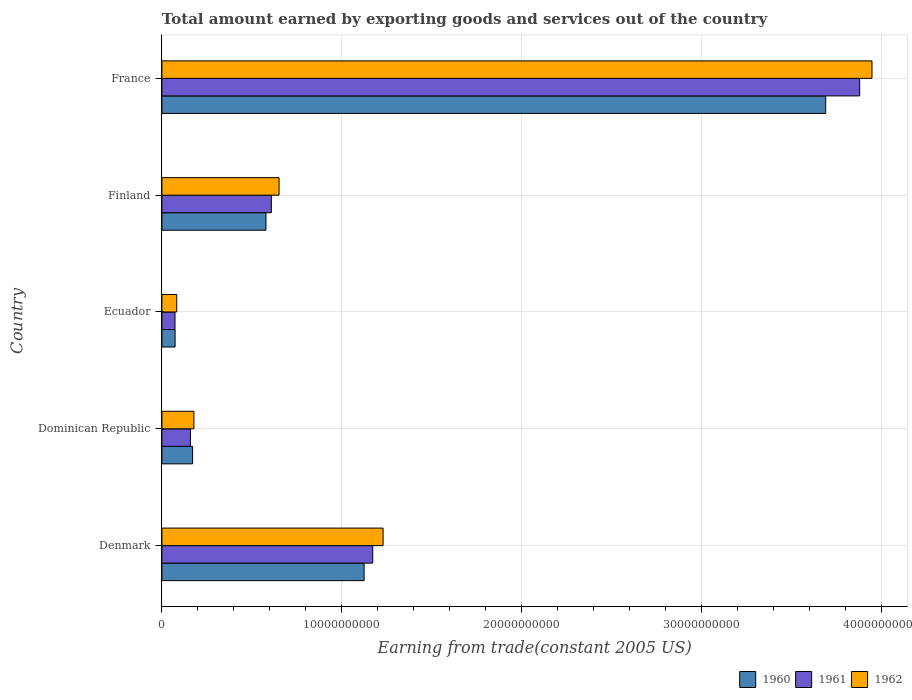How many different coloured bars are there?
Offer a terse response. 3. How many groups of bars are there?
Provide a succinct answer. 5. Are the number of bars per tick equal to the number of legend labels?
Your answer should be compact. Yes. How many bars are there on the 2nd tick from the top?
Your answer should be very brief. 3. How many bars are there on the 5th tick from the bottom?
Provide a short and direct response. 3. In how many cases, is the number of bars for a given country not equal to the number of legend labels?
Provide a short and direct response. 0. What is the total amount earned by exporting goods and services in 1961 in Ecuador?
Make the answer very short. 7.28e+08. Across all countries, what is the maximum total amount earned by exporting goods and services in 1961?
Make the answer very short. 3.88e+1. Across all countries, what is the minimum total amount earned by exporting goods and services in 1962?
Make the answer very short. 8.25e+08. In which country was the total amount earned by exporting goods and services in 1962 maximum?
Offer a very short reply. France. In which country was the total amount earned by exporting goods and services in 1962 minimum?
Ensure brevity in your answer.  Ecuador. What is the total total amount earned by exporting goods and services in 1960 in the graph?
Your answer should be very brief. 5.64e+1. What is the difference between the total amount earned by exporting goods and services in 1962 in Denmark and that in Dominican Republic?
Give a very brief answer. 1.05e+1. What is the difference between the total amount earned by exporting goods and services in 1961 in France and the total amount earned by exporting goods and services in 1962 in Dominican Republic?
Offer a very short reply. 3.70e+1. What is the average total amount earned by exporting goods and services in 1960 per country?
Provide a short and direct response. 1.13e+1. What is the difference between the total amount earned by exporting goods and services in 1961 and total amount earned by exporting goods and services in 1960 in Dominican Republic?
Give a very brief answer. -1.20e+08. What is the ratio of the total amount earned by exporting goods and services in 1962 in Ecuador to that in France?
Your answer should be very brief. 0.02. Is the difference between the total amount earned by exporting goods and services in 1961 in Dominican Republic and France greater than the difference between the total amount earned by exporting goods and services in 1960 in Dominican Republic and France?
Provide a succinct answer. No. What is the difference between the highest and the second highest total amount earned by exporting goods and services in 1961?
Offer a terse response. 2.71e+1. What is the difference between the highest and the lowest total amount earned by exporting goods and services in 1962?
Your response must be concise. 3.86e+1. What does the 2nd bar from the top in Dominican Republic represents?
Make the answer very short. 1961. Is it the case that in every country, the sum of the total amount earned by exporting goods and services in 1961 and total amount earned by exporting goods and services in 1962 is greater than the total amount earned by exporting goods and services in 1960?
Provide a short and direct response. Yes. How many bars are there?
Provide a short and direct response. 15. Are the values on the major ticks of X-axis written in scientific E-notation?
Provide a short and direct response. No. Does the graph contain any zero values?
Keep it short and to the point. No. What is the title of the graph?
Give a very brief answer. Total amount earned by exporting goods and services out of the country. Does "2011" appear as one of the legend labels in the graph?
Your answer should be very brief. No. What is the label or title of the X-axis?
Give a very brief answer. Earning from trade(constant 2005 US). What is the label or title of the Y-axis?
Your answer should be compact. Country. What is the Earning from trade(constant 2005 US) of 1960 in Denmark?
Offer a terse response. 1.12e+1. What is the Earning from trade(constant 2005 US) of 1961 in Denmark?
Offer a very short reply. 1.17e+1. What is the Earning from trade(constant 2005 US) of 1962 in Denmark?
Your response must be concise. 1.23e+1. What is the Earning from trade(constant 2005 US) in 1960 in Dominican Republic?
Provide a succinct answer. 1.71e+09. What is the Earning from trade(constant 2005 US) of 1961 in Dominican Republic?
Ensure brevity in your answer.  1.59e+09. What is the Earning from trade(constant 2005 US) in 1962 in Dominican Republic?
Keep it short and to the point. 1.78e+09. What is the Earning from trade(constant 2005 US) of 1960 in Ecuador?
Provide a succinct answer. 7.33e+08. What is the Earning from trade(constant 2005 US) in 1961 in Ecuador?
Provide a short and direct response. 7.28e+08. What is the Earning from trade(constant 2005 US) of 1962 in Ecuador?
Provide a short and direct response. 8.25e+08. What is the Earning from trade(constant 2005 US) of 1960 in Finland?
Ensure brevity in your answer.  5.78e+09. What is the Earning from trade(constant 2005 US) of 1961 in Finland?
Your answer should be compact. 6.08e+09. What is the Earning from trade(constant 2005 US) of 1962 in Finland?
Your answer should be very brief. 6.51e+09. What is the Earning from trade(constant 2005 US) in 1960 in France?
Give a very brief answer. 3.69e+1. What is the Earning from trade(constant 2005 US) of 1961 in France?
Offer a very short reply. 3.88e+1. What is the Earning from trade(constant 2005 US) in 1962 in France?
Provide a short and direct response. 3.95e+1. Across all countries, what is the maximum Earning from trade(constant 2005 US) in 1960?
Provide a succinct answer. 3.69e+1. Across all countries, what is the maximum Earning from trade(constant 2005 US) in 1961?
Keep it short and to the point. 3.88e+1. Across all countries, what is the maximum Earning from trade(constant 2005 US) in 1962?
Your answer should be very brief. 3.95e+1. Across all countries, what is the minimum Earning from trade(constant 2005 US) in 1960?
Offer a terse response. 7.33e+08. Across all countries, what is the minimum Earning from trade(constant 2005 US) in 1961?
Offer a very short reply. 7.28e+08. Across all countries, what is the minimum Earning from trade(constant 2005 US) of 1962?
Your answer should be compact. 8.25e+08. What is the total Earning from trade(constant 2005 US) in 1960 in the graph?
Ensure brevity in your answer.  5.64e+1. What is the total Earning from trade(constant 2005 US) in 1961 in the graph?
Offer a very short reply. 5.89e+1. What is the total Earning from trade(constant 2005 US) of 1962 in the graph?
Your answer should be very brief. 6.09e+1. What is the difference between the Earning from trade(constant 2005 US) in 1960 in Denmark and that in Dominican Republic?
Your answer should be compact. 9.53e+09. What is the difference between the Earning from trade(constant 2005 US) of 1961 in Denmark and that in Dominican Republic?
Keep it short and to the point. 1.01e+1. What is the difference between the Earning from trade(constant 2005 US) in 1962 in Denmark and that in Dominican Republic?
Ensure brevity in your answer.  1.05e+1. What is the difference between the Earning from trade(constant 2005 US) of 1960 in Denmark and that in Ecuador?
Your answer should be very brief. 1.05e+1. What is the difference between the Earning from trade(constant 2005 US) in 1961 in Denmark and that in Ecuador?
Your response must be concise. 1.10e+1. What is the difference between the Earning from trade(constant 2005 US) in 1962 in Denmark and that in Ecuador?
Provide a short and direct response. 1.15e+1. What is the difference between the Earning from trade(constant 2005 US) of 1960 in Denmark and that in Finland?
Make the answer very short. 5.45e+09. What is the difference between the Earning from trade(constant 2005 US) in 1961 in Denmark and that in Finland?
Keep it short and to the point. 5.64e+09. What is the difference between the Earning from trade(constant 2005 US) of 1962 in Denmark and that in Finland?
Your response must be concise. 5.78e+09. What is the difference between the Earning from trade(constant 2005 US) of 1960 in Denmark and that in France?
Offer a very short reply. -2.57e+1. What is the difference between the Earning from trade(constant 2005 US) in 1961 in Denmark and that in France?
Ensure brevity in your answer.  -2.71e+1. What is the difference between the Earning from trade(constant 2005 US) in 1962 in Denmark and that in France?
Make the answer very short. -2.72e+1. What is the difference between the Earning from trade(constant 2005 US) of 1960 in Dominican Republic and that in Ecuador?
Offer a terse response. 9.74e+08. What is the difference between the Earning from trade(constant 2005 US) in 1961 in Dominican Republic and that in Ecuador?
Make the answer very short. 8.59e+08. What is the difference between the Earning from trade(constant 2005 US) in 1962 in Dominican Republic and that in Ecuador?
Ensure brevity in your answer.  9.54e+08. What is the difference between the Earning from trade(constant 2005 US) in 1960 in Dominican Republic and that in Finland?
Offer a very short reply. -4.08e+09. What is the difference between the Earning from trade(constant 2005 US) in 1961 in Dominican Republic and that in Finland?
Your answer should be compact. -4.50e+09. What is the difference between the Earning from trade(constant 2005 US) of 1962 in Dominican Republic and that in Finland?
Give a very brief answer. -4.73e+09. What is the difference between the Earning from trade(constant 2005 US) in 1960 in Dominican Republic and that in France?
Ensure brevity in your answer.  -3.52e+1. What is the difference between the Earning from trade(constant 2005 US) of 1961 in Dominican Republic and that in France?
Offer a very short reply. -3.72e+1. What is the difference between the Earning from trade(constant 2005 US) in 1962 in Dominican Republic and that in France?
Offer a very short reply. -3.77e+1. What is the difference between the Earning from trade(constant 2005 US) in 1960 in Ecuador and that in Finland?
Offer a terse response. -5.05e+09. What is the difference between the Earning from trade(constant 2005 US) in 1961 in Ecuador and that in Finland?
Provide a succinct answer. -5.35e+09. What is the difference between the Earning from trade(constant 2005 US) in 1962 in Ecuador and that in Finland?
Ensure brevity in your answer.  -5.69e+09. What is the difference between the Earning from trade(constant 2005 US) in 1960 in Ecuador and that in France?
Give a very brief answer. -3.62e+1. What is the difference between the Earning from trade(constant 2005 US) in 1961 in Ecuador and that in France?
Ensure brevity in your answer.  -3.81e+1. What is the difference between the Earning from trade(constant 2005 US) of 1962 in Ecuador and that in France?
Your answer should be very brief. -3.86e+1. What is the difference between the Earning from trade(constant 2005 US) of 1960 in Finland and that in France?
Your answer should be compact. -3.11e+1. What is the difference between the Earning from trade(constant 2005 US) in 1961 in Finland and that in France?
Your answer should be very brief. -3.27e+1. What is the difference between the Earning from trade(constant 2005 US) of 1962 in Finland and that in France?
Provide a short and direct response. -3.30e+1. What is the difference between the Earning from trade(constant 2005 US) in 1960 in Denmark and the Earning from trade(constant 2005 US) in 1961 in Dominican Republic?
Provide a succinct answer. 9.65e+09. What is the difference between the Earning from trade(constant 2005 US) in 1960 in Denmark and the Earning from trade(constant 2005 US) in 1962 in Dominican Republic?
Make the answer very short. 9.46e+09. What is the difference between the Earning from trade(constant 2005 US) of 1961 in Denmark and the Earning from trade(constant 2005 US) of 1962 in Dominican Republic?
Your answer should be very brief. 9.94e+09. What is the difference between the Earning from trade(constant 2005 US) of 1960 in Denmark and the Earning from trade(constant 2005 US) of 1961 in Ecuador?
Ensure brevity in your answer.  1.05e+1. What is the difference between the Earning from trade(constant 2005 US) of 1960 in Denmark and the Earning from trade(constant 2005 US) of 1962 in Ecuador?
Offer a very short reply. 1.04e+1. What is the difference between the Earning from trade(constant 2005 US) of 1961 in Denmark and the Earning from trade(constant 2005 US) of 1962 in Ecuador?
Give a very brief answer. 1.09e+1. What is the difference between the Earning from trade(constant 2005 US) of 1960 in Denmark and the Earning from trade(constant 2005 US) of 1961 in Finland?
Make the answer very short. 5.16e+09. What is the difference between the Earning from trade(constant 2005 US) in 1960 in Denmark and the Earning from trade(constant 2005 US) in 1962 in Finland?
Your response must be concise. 4.73e+09. What is the difference between the Earning from trade(constant 2005 US) in 1961 in Denmark and the Earning from trade(constant 2005 US) in 1962 in Finland?
Your answer should be compact. 5.21e+09. What is the difference between the Earning from trade(constant 2005 US) in 1960 in Denmark and the Earning from trade(constant 2005 US) in 1961 in France?
Ensure brevity in your answer.  -2.75e+1. What is the difference between the Earning from trade(constant 2005 US) in 1960 in Denmark and the Earning from trade(constant 2005 US) in 1962 in France?
Your answer should be compact. -2.82e+1. What is the difference between the Earning from trade(constant 2005 US) in 1961 in Denmark and the Earning from trade(constant 2005 US) in 1962 in France?
Make the answer very short. -2.77e+1. What is the difference between the Earning from trade(constant 2005 US) in 1960 in Dominican Republic and the Earning from trade(constant 2005 US) in 1961 in Ecuador?
Give a very brief answer. 9.79e+08. What is the difference between the Earning from trade(constant 2005 US) in 1960 in Dominican Republic and the Earning from trade(constant 2005 US) in 1962 in Ecuador?
Provide a succinct answer. 8.81e+08. What is the difference between the Earning from trade(constant 2005 US) of 1961 in Dominican Republic and the Earning from trade(constant 2005 US) of 1962 in Ecuador?
Ensure brevity in your answer.  7.61e+08. What is the difference between the Earning from trade(constant 2005 US) of 1960 in Dominican Republic and the Earning from trade(constant 2005 US) of 1961 in Finland?
Keep it short and to the point. -4.38e+09. What is the difference between the Earning from trade(constant 2005 US) in 1960 in Dominican Republic and the Earning from trade(constant 2005 US) in 1962 in Finland?
Ensure brevity in your answer.  -4.81e+09. What is the difference between the Earning from trade(constant 2005 US) in 1961 in Dominican Republic and the Earning from trade(constant 2005 US) in 1962 in Finland?
Give a very brief answer. -4.93e+09. What is the difference between the Earning from trade(constant 2005 US) in 1960 in Dominican Republic and the Earning from trade(constant 2005 US) in 1961 in France?
Keep it short and to the point. -3.71e+1. What is the difference between the Earning from trade(constant 2005 US) in 1960 in Dominican Republic and the Earning from trade(constant 2005 US) in 1962 in France?
Ensure brevity in your answer.  -3.78e+1. What is the difference between the Earning from trade(constant 2005 US) of 1961 in Dominican Republic and the Earning from trade(constant 2005 US) of 1962 in France?
Your response must be concise. -3.79e+1. What is the difference between the Earning from trade(constant 2005 US) in 1960 in Ecuador and the Earning from trade(constant 2005 US) in 1961 in Finland?
Keep it short and to the point. -5.35e+09. What is the difference between the Earning from trade(constant 2005 US) in 1960 in Ecuador and the Earning from trade(constant 2005 US) in 1962 in Finland?
Provide a succinct answer. -5.78e+09. What is the difference between the Earning from trade(constant 2005 US) in 1961 in Ecuador and the Earning from trade(constant 2005 US) in 1962 in Finland?
Offer a very short reply. -5.78e+09. What is the difference between the Earning from trade(constant 2005 US) in 1960 in Ecuador and the Earning from trade(constant 2005 US) in 1961 in France?
Offer a terse response. -3.81e+1. What is the difference between the Earning from trade(constant 2005 US) in 1960 in Ecuador and the Earning from trade(constant 2005 US) in 1962 in France?
Offer a very short reply. -3.87e+1. What is the difference between the Earning from trade(constant 2005 US) of 1961 in Ecuador and the Earning from trade(constant 2005 US) of 1962 in France?
Offer a terse response. -3.87e+1. What is the difference between the Earning from trade(constant 2005 US) of 1960 in Finland and the Earning from trade(constant 2005 US) of 1961 in France?
Give a very brief answer. -3.30e+1. What is the difference between the Earning from trade(constant 2005 US) in 1960 in Finland and the Earning from trade(constant 2005 US) in 1962 in France?
Provide a short and direct response. -3.37e+1. What is the difference between the Earning from trade(constant 2005 US) of 1961 in Finland and the Earning from trade(constant 2005 US) of 1962 in France?
Your answer should be very brief. -3.34e+1. What is the average Earning from trade(constant 2005 US) of 1960 per country?
Offer a terse response. 1.13e+1. What is the average Earning from trade(constant 2005 US) of 1961 per country?
Provide a short and direct response. 1.18e+1. What is the average Earning from trade(constant 2005 US) of 1962 per country?
Ensure brevity in your answer.  1.22e+1. What is the difference between the Earning from trade(constant 2005 US) in 1960 and Earning from trade(constant 2005 US) in 1961 in Denmark?
Offer a terse response. -4.81e+08. What is the difference between the Earning from trade(constant 2005 US) in 1960 and Earning from trade(constant 2005 US) in 1962 in Denmark?
Keep it short and to the point. -1.06e+09. What is the difference between the Earning from trade(constant 2005 US) of 1961 and Earning from trade(constant 2005 US) of 1962 in Denmark?
Give a very brief answer. -5.76e+08. What is the difference between the Earning from trade(constant 2005 US) in 1960 and Earning from trade(constant 2005 US) in 1961 in Dominican Republic?
Your response must be concise. 1.20e+08. What is the difference between the Earning from trade(constant 2005 US) in 1960 and Earning from trade(constant 2005 US) in 1962 in Dominican Republic?
Keep it short and to the point. -7.23e+07. What is the difference between the Earning from trade(constant 2005 US) in 1961 and Earning from trade(constant 2005 US) in 1962 in Dominican Republic?
Your response must be concise. -1.92e+08. What is the difference between the Earning from trade(constant 2005 US) in 1960 and Earning from trade(constant 2005 US) in 1961 in Ecuador?
Make the answer very short. 5.42e+06. What is the difference between the Earning from trade(constant 2005 US) of 1960 and Earning from trade(constant 2005 US) of 1962 in Ecuador?
Your answer should be compact. -9.21e+07. What is the difference between the Earning from trade(constant 2005 US) of 1961 and Earning from trade(constant 2005 US) of 1962 in Ecuador?
Offer a very short reply. -9.75e+07. What is the difference between the Earning from trade(constant 2005 US) in 1960 and Earning from trade(constant 2005 US) in 1961 in Finland?
Provide a short and direct response. -2.97e+08. What is the difference between the Earning from trade(constant 2005 US) in 1960 and Earning from trade(constant 2005 US) in 1962 in Finland?
Ensure brevity in your answer.  -7.27e+08. What is the difference between the Earning from trade(constant 2005 US) of 1961 and Earning from trade(constant 2005 US) of 1962 in Finland?
Make the answer very short. -4.30e+08. What is the difference between the Earning from trade(constant 2005 US) of 1960 and Earning from trade(constant 2005 US) of 1961 in France?
Your response must be concise. -1.89e+09. What is the difference between the Earning from trade(constant 2005 US) of 1960 and Earning from trade(constant 2005 US) of 1962 in France?
Offer a very short reply. -2.57e+09. What is the difference between the Earning from trade(constant 2005 US) in 1961 and Earning from trade(constant 2005 US) in 1962 in France?
Offer a very short reply. -6.85e+08. What is the ratio of the Earning from trade(constant 2005 US) of 1960 in Denmark to that in Dominican Republic?
Ensure brevity in your answer.  6.59. What is the ratio of the Earning from trade(constant 2005 US) of 1961 in Denmark to that in Dominican Republic?
Your answer should be compact. 7.39. What is the ratio of the Earning from trade(constant 2005 US) in 1962 in Denmark to that in Dominican Republic?
Ensure brevity in your answer.  6.91. What is the ratio of the Earning from trade(constant 2005 US) of 1960 in Denmark to that in Ecuador?
Your answer should be very brief. 15.33. What is the ratio of the Earning from trade(constant 2005 US) of 1961 in Denmark to that in Ecuador?
Keep it short and to the point. 16.1. What is the ratio of the Earning from trade(constant 2005 US) of 1962 in Denmark to that in Ecuador?
Ensure brevity in your answer.  14.9. What is the ratio of the Earning from trade(constant 2005 US) of 1960 in Denmark to that in Finland?
Give a very brief answer. 1.94. What is the ratio of the Earning from trade(constant 2005 US) of 1961 in Denmark to that in Finland?
Provide a succinct answer. 1.93. What is the ratio of the Earning from trade(constant 2005 US) in 1962 in Denmark to that in Finland?
Your response must be concise. 1.89. What is the ratio of the Earning from trade(constant 2005 US) in 1960 in Denmark to that in France?
Your response must be concise. 0.3. What is the ratio of the Earning from trade(constant 2005 US) of 1961 in Denmark to that in France?
Your answer should be very brief. 0.3. What is the ratio of the Earning from trade(constant 2005 US) of 1962 in Denmark to that in France?
Ensure brevity in your answer.  0.31. What is the ratio of the Earning from trade(constant 2005 US) in 1960 in Dominican Republic to that in Ecuador?
Keep it short and to the point. 2.33. What is the ratio of the Earning from trade(constant 2005 US) of 1961 in Dominican Republic to that in Ecuador?
Give a very brief answer. 2.18. What is the ratio of the Earning from trade(constant 2005 US) in 1962 in Dominican Republic to that in Ecuador?
Your answer should be compact. 2.16. What is the ratio of the Earning from trade(constant 2005 US) of 1960 in Dominican Republic to that in Finland?
Make the answer very short. 0.29. What is the ratio of the Earning from trade(constant 2005 US) in 1961 in Dominican Republic to that in Finland?
Keep it short and to the point. 0.26. What is the ratio of the Earning from trade(constant 2005 US) in 1962 in Dominican Republic to that in Finland?
Provide a short and direct response. 0.27. What is the ratio of the Earning from trade(constant 2005 US) of 1960 in Dominican Republic to that in France?
Keep it short and to the point. 0.05. What is the ratio of the Earning from trade(constant 2005 US) of 1961 in Dominican Republic to that in France?
Make the answer very short. 0.04. What is the ratio of the Earning from trade(constant 2005 US) in 1962 in Dominican Republic to that in France?
Provide a succinct answer. 0.05. What is the ratio of the Earning from trade(constant 2005 US) in 1960 in Ecuador to that in Finland?
Offer a terse response. 0.13. What is the ratio of the Earning from trade(constant 2005 US) of 1961 in Ecuador to that in Finland?
Ensure brevity in your answer.  0.12. What is the ratio of the Earning from trade(constant 2005 US) in 1962 in Ecuador to that in Finland?
Your response must be concise. 0.13. What is the ratio of the Earning from trade(constant 2005 US) of 1960 in Ecuador to that in France?
Your answer should be compact. 0.02. What is the ratio of the Earning from trade(constant 2005 US) in 1961 in Ecuador to that in France?
Give a very brief answer. 0.02. What is the ratio of the Earning from trade(constant 2005 US) of 1962 in Ecuador to that in France?
Your answer should be compact. 0.02. What is the ratio of the Earning from trade(constant 2005 US) of 1960 in Finland to that in France?
Provide a short and direct response. 0.16. What is the ratio of the Earning from trade(constant 2005 US) in 1961 in Finland to that in France?
Provide a short and direct response. 0.16. What is the ratio of the Earning from trade(constant 2005 US) in 1962 in Finland to that in France?
Provide a short and direct response. 0.17. What is the difference between the highest and the second highest Earning from trade(constant 2005 US) in 1960?
Your answer should be very brief. 2.57e+1. What is the difference between the highest and the second highest Earning from trade(constant 2005 US) of 1961?
Provide a succinct answer. 2.71e+1. What is the difference between the highest and the second highest Earning from trade(constant 2005 US) in 1962?
Your answer should be very brief. 2.72e+1. What is the difference between the highest and the lowest Earning from trade(constant 2005 US) in 1960?
Give a very brief answer. 3.62e+1. What is the difference between the highest and the lowest Earning from trade(constant 2005 US) in 1961?
Provide a short and direct response. 3.81e+1. What is the difference between the highest and the lowest Earning from trade(constant 2005 US) of 1962?
Make the answer very short. 3.86e+1. 